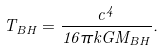<formula> <loc_0><loc_0><loc_500><loc_500>T _ { B H } = \frac { c ^ { 4 } } { 1 6 \pi k G M _ { B H } } .</formula> 